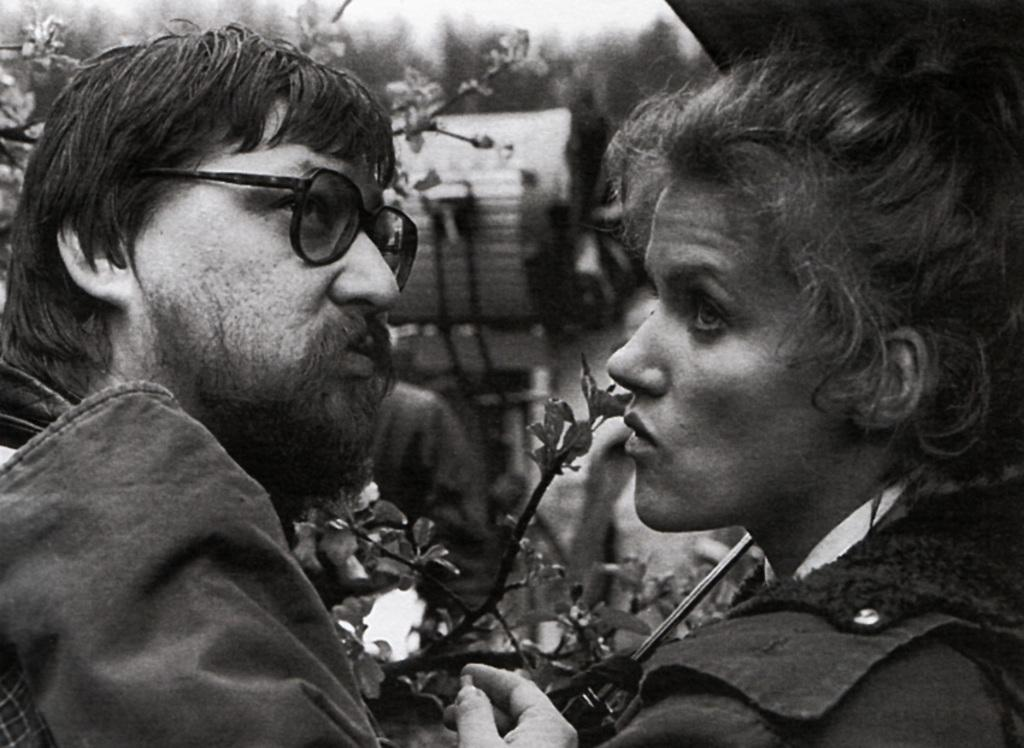How many people are in the image? There are two persons in the foreground of the image. What can be seen besides the people in the image? Plants are visible in the image. What else can be observed in the background of the image? There are other objects in the background of the image. What type of cord is being used to create a quiet atmosphere in the image? There is no mention of a cord or a quiet atmosphere in the image. The image features two people and plants, but no cords or sound-related elements are present. 